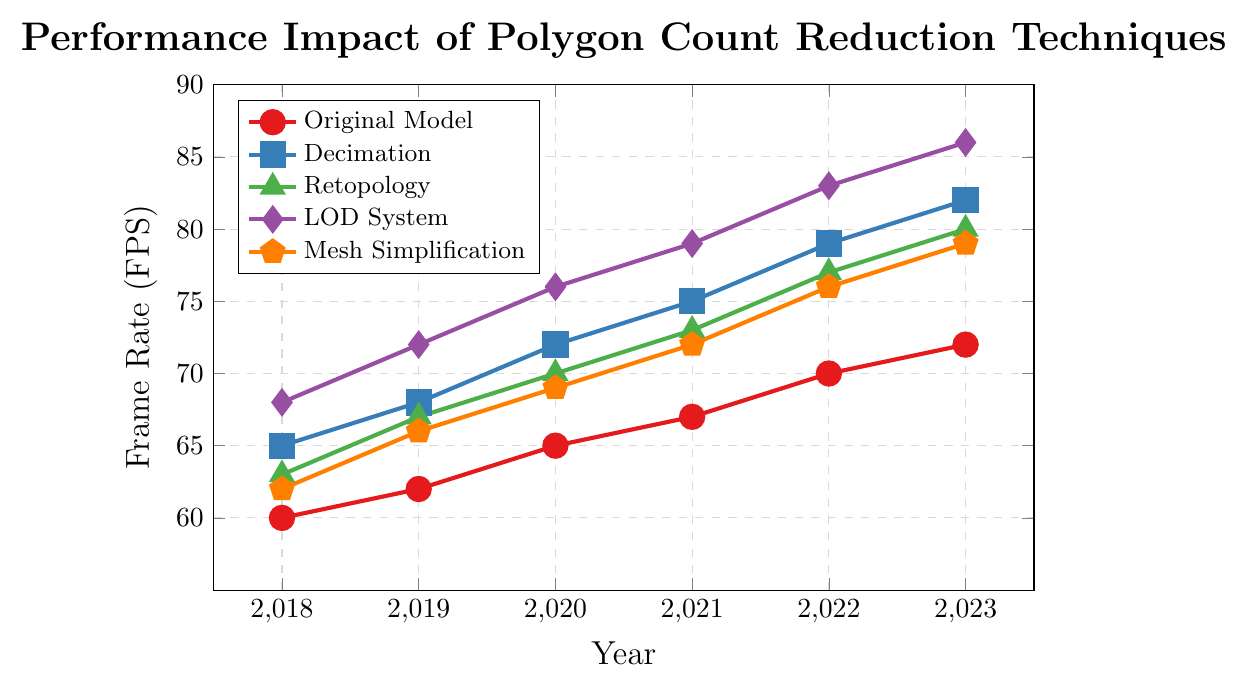What is the average frame rate of the Original Model from 2018 to 2023? To find the average frame rate of the Original Model, sum the values from 2018 to 2023 and then divide by the number of years. The values are 60, 62, 65, 67, 70, and 72. The sum is \(60 + 62 + 65 + 67 + 70 + 72 = 396\). Divide by 6 (the number of years), \(396 / 6 = 66\)
Answer: 66 Which technique had the highest frame rate in 2023? To determine the technique with the highest frame rate in 2023, compare the frame rates of each technique in that year. The values are: Original Model: 72, Decimation: 82, Retopology: 80, LOD System: 86, Mesh Simplification: 79. The highest value is 86 for the LOD System
Answer: LOD System How much did the frame rate of the LOD System increase from 2019 to 2023? To find the increase, subtract the frame rate of the LOD System in 2019 from that in 2023. The values are 72 (in 2019) and 86 (in 2023). The difference is \(86 - 72 = 14\)
Answer: 14 By how many FPS does the Decimation technique outperform the Original Model, on average, over the years? First, calculate the difference between the Decimation and the Original Model for each year: \(65-60, 68-62, 72-65, 75-67, 79-70, 82-72\). This gives differences of 5, 6, 7, 8, 9, and 10. Sum these differences: \(5 + 6 + 7 + 8 + 9 + 10 = 45\). Divide by the number of years: \(45 / 6 = 7.5\)
Answer: 7.5 Which technique showed the steadiest improvement in frame rate year over year, and what was the average annual increase? To determine the steadiest improvement, look for the technique with the smallest variance in annual increases. Calculate annual increases for each technique and find their average:
- Original Model: \((62-60), (65-62), (67-65), (70-67), (72-70)\) -> 2, 3, 2, 3, 2 (average = \(12/5\))
- Decimation: \((68-65), (72-68), (75-72), (79-75), (82-79)\) -> 3, 4, 3, 4, 3 (average = \(17/5\))
- Retopology: \((67-63), (70-67), (73-70), (77-73), (80-77)\) -> 4, 3, 3, 4, 3 (average = \(17/5\))
- LOD System: \((72-68), (76-72), (79-76), (83-79), (86-83)\) -> 4, 4, 3, 4, 3 (average = \(18/5\))
- Mesh Simplification: \((66-62), (69-66), (72-69), (76-72), (79-76)\) -> 4, 3, 3, 4, 3 (average = \(17/5\))
LOD System shows the steadiest improvement annually with an average increase of \(3.6\)
Answer: LOD System, 3.6 What is the total frame rate gain for the Retopology technique from 2018 to 2023? Compute the gain by subtracting the frame rate in 2018 from the frame rate in 2023 for the Retopology technique. The values are 80 (in 2023) and 63 (in 2018). The difference is \(80 - 63 = 17\)
Answer: 17 